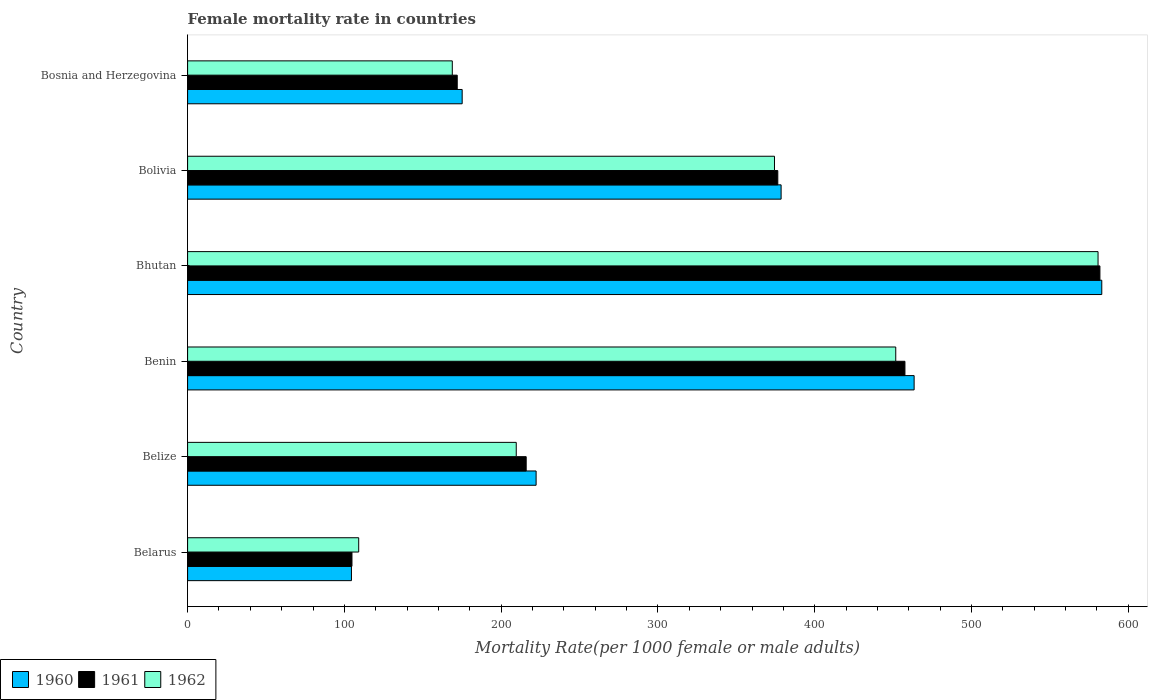How many different coloured bars are there?
Your response must be concise. 3. How many groups of bars are there?
Offer a very short reply. 6. How many bars are there on the 6th tick from the top?
Keep it short and to the point. 3. How many bars are there on the 4th tick from the bottom?
Your answer should be very brief. 3. What is the label of the 6th group of bars from the top?
Offer a very short reply. Belarus. In how many cases, is the number of bars for a given country not equal to the number of legend labels?
Offer a very short reply. 0. What is the female mortality rate in 1960 in Bosnia and Herzegovina?
Offer a terse response. 175.12. Across all countries, what is the maximum female mortality rate in 1961?
Offer a terse response. 581.88. Across all countries, what is the minimum female mortality rate in 1960?
Offer a terse response. 104.51. In which country was the female mortality rate in 1962 maximum?
Your answer should be compact. Bhutan. In which country was the female mortality rate in 1961 minimum?
Provide a succinct answer. Belarus. What is the total female mortality rate in 1962 in the graph?
Keep it short and to the point. 1894.24. What is the difference between the female mortality rate in 1960 in Benin and that in Bosnia and Herzegovina?
Make the answer very short. 288.25. What is the difference between the female mortality rate in 1960 in Belize and the female mortality rate in 1962 in Benin?
Offer a terse response. -229.38. What is the average female mortality rate in 1962 per country?
Offer a terse response. 315.71. What is the difference between the female mortality rate in 1962 and female mortality rate in 1961 in Belarus?
Your answer should be very brief. 4.29. In how many countries, is the female mortality rate in 1962 greater than 340 ?
Ensure brevity in your answer.  3. What is the ratio of the female mortality rate in 1960 in Bhutan to that in Bolivia?
Offer a very short reply. 1.54. Is the difference between the female mortality rate in 1962 in Belarus and Bhutan greater than the difference between the female mortality rate in 1961 in Belarus and Bhutan?
Offer a terse response. Yes. What is the difference between the highest and the second highest female mortality rate in 1961?
Your answer should be very brief. 124.36. What is the difference between the highest and the lowest female mortality rate in 1960?
Make the answer very short. 478.56. In how many countries, is the female mortality rate in 1960 greater than the average female mortality rate in 1960 taken over all countries?
Offer a terse response. 3. Is the sum of the female mortality rate in 1962 in Benin and Bosnia and Herzegovina greater than the maximum female mortality rate in 1961 across all countries?
Provide a short and direct response. Yes. What does the 2nd bar from the top in Belarus represents?
Offer a very short reply. 1961. How many bars are there?
Your response must be concise. 18. Are all the bars in the graph horizontal?
Provide a short and direct response. Yes. Are the values on the major ticks of X-axis written in scientific E-notation?
Make the answer very short. No. Does the graph contain any zero values?
Give a very brief answer. No. How many legend labels are there?
Your answer should be compact. 3. How are the legend labels stacked?
Offer a terse response. Horizontal. What is the title of the graph?
Your answer should be very brief. Female mortality rate in countries. Does "1961" appear as one of the legend labels in the graph?
Offer a very short reply. Yes. What is the label or title of the X-axis?
Your answer should be compact. Mortality Rate(per 1000 female or male adults). What is the Mortality Rate(per 1000 female or male adults) in 1960 in Belarus?
Give a very brief answer. 104.51. What is the Mortality Rate(per 1000 female or male adults) of 1961 in Belarus?
Keep it short and to the point. 104.84. What is the Mortality Rate(per 1000 female or male adults) of 1962 in Belarus?
Give a very brief answer. 109.13. What is the Mortality Rate(per 1000 female or male adults) of 1960 in Belize?
Give a very brief answer. 222.28. What is the Mortality Rate(per 1000 female or male adults) of 1961 in Belize?
Keep it short and to the point. 215.95. What is the Mortality Rate(per 1000 female or male adults) in 1962 in Belize?
Provide a short and direct response. 209.62. What is the Mortality Rate(per 1000 female or male adults) of 1960 in Benin?
Make the answer very short. 463.38. What is the Mortality Rate(per 1000 female or male adults) in 1961 in Benin?
Your answer should be very brief. 457.52. What is the Mortality Rate(per 1000 female or male adults) in 1962 in Benin?
Your answer should be compact. 451.66. What is the Mortality Rate(per 1000 female or male adults) in 1960 in Bhutan?
Keep it short and to the point. 583.07. What is the Mortality Rate(per 1000 female or male adults) in 1961 in Bhutan?
Offer a very short reply. 581.88. What is the Mortality Rate(per 1000 female or male adults) of 1962 in Bhutan?
Provide a succinct answer. 580.69. What is the Mortality Rate(per 1000 female or male adults) of 1960 in Bolivia?
Give a very brief answer. 378.54. What is the Mortality Rate(per 1000 female or male adults) of 1961 in Bolivia?
Your answer should be compact. 376.43. What is the Mortality Rate(per 1000 female or male adults) of 1962 in Bolivia?
Your answer should be compact. 374.32. What is the Mortality Rate(per 1000 female or male adults) of 1960 in Bosnia and Herzegovina?
Offer a very short reply. 175.12. What is the Mortality Rate(per 1000 female or male adults) in 1961 in Bosnia and Herzegovina?
Offer a very short reply. 171.98. What is the Mortality Rate(per 1000 female or male adults) in 1962 in Bosnia and Herzegovina?
Give a very brief answer. 168.83. Across all countries, what is the maximum Mortality Rate(per 1000 female or male adults) in 1960?
Give a very brief answer. 583.07. Across all countries, what is the maximum Mortality Rate(per 1000 female or male adults) in 1961?
Make the answer very short. 581.88. Across all countries, what is the maximum Mortality Rate(per 1000 female or male adults) in 1962?
Give a very brief answer. 580.69. Across all countries, what is the minimum Mortality Rate(per 1000 female or male adults) in 1960?
Provide a succinct answer. 104.51. Across all countries, what is the minimum Mortality Rate(per 1000 female or male adults) in 1961?
Your answer should be very brief. 104.84. Across all countries, what is the minimum Mortality Rate(per 1000 female or male adults) in 1962?
Make the answer very short. 109.13. What is the total Mortality Rate(per 1000 female or male adults) in 1960 in the graph?
Keep it short and to the point. 1926.9. What is the total Mortality Rate(per 1000 female or male adults) in 1961 in the graph?
Your response must be concise. 1908.59. What is the total Mortality Rate(per 1000 female or male adults) of 1962 in the graph?
Keep it short and to the point. 1894.24. What is the difference between the Mortality Rate(per 1000 female or male adults) in 1960 in Belarus and that in Belize?
Give a very brief answer. -117.77. What is the difference between the Mortality Rate(per 1000 female or male adults) in 1961 in Belarus and that in Belize?
Offer a terse response. -111.11. What is the difference between the Mortality Rate(per 1000 female or male adults) of 1962 in Belarus and that in Belize?
Offer a very short reply. -100.49. What is the difference between the Mortality Rate(per 1000 female or male adults) in 1960 in Belarus and that in Benin?
Give a very brief answer. -358.87. What is the difference between the Mortality Rate(per 1000 female or male adults) of 1961 in Belarus and that in Benin?
Offer a very short reply. -352.68. What is the difference between the Mortality Rate(per 1000 female or male adults) in 1962 in Belarus and that in Benin?
Provide a succinct answer. -342.53. What is the difference between the Mortality Rate(per 1000 female or male adults) in 1960 in Belarus and that in Bhutan?
Make the answer very short. -478.56. What is the difference between the Mortality Rate(per 1000 female or male adults) in 1961 in Belarus and that in Bhutan?
Make the answer very short. -477.04. What is the difference between the Mortality Rate(per 1000 female or male adults) of 1962 in Belarus and that in Bhutan?
Ensure brevity in your answer.  -471.56. What is the difference between the Mortality Rate(per 1000 female or male adults) in 1960 in Belarus and that in Bolivia?
Make the answer very short. -274.03. What is the difference between the Mortality Rate(per 1000 female or male adults) in 1961 in Belarus and that in Bolivia?
Provide a succinct answer. -271.59. What is the difference between the Mortality Rate(per 1000 female or male adults) in 1962 in Belarus and that in Bolivia?
Offer a terse response. -265.19. What is the difference between the Mortality Rate(per 1000 female or male adults) in 1960 in Belarus and that in Bosnia and Herzegovina?
Offer a very short reply. -70.62. What is the difference between the Mortality Rate(per 1000 female or male adults) of 1961 in Belarus and that in Bosnia and Herzegovina?
Keep it short and to the point. -67.14. What is the difference between the Mortality Rate(per 1000 female or male adults) in 1962 in Belarus and that in Bosnia and Herzegovina?
Give a very brief answer. -59.7. What is the difference between the Mortality Rate(per 1000 female or male adults) in 1960 in Belize and that in Benin?
Give a very brief answer. -241.1. What is the difference between the Mortality Rate(per 1000 female or male adults) in 1961 in Belize and that in Benin?
Ensure brevity in your answer.  -241.57. What is the difference between the Mortality Rate(per 1000 female or male adults) of 1962 in Belize and that in Benin?
Provide a succinct answer. -242.04. What is the difference between the Mortality Rate(per 1000 female or male adults) of 1960 in Belize and that in Bhutan?
Your response must be concise. -360.79. What is the difference between the Mortality Rate(per 1000 female or male adults) in 1961 in Belize and that in Bhutan?
Keep it short and to the point. -365.93. What is the difference between the Mortality Rate(per 1000 female or male adults) of 1962 in Belize and that in Bhutan?
Make the answer very short. -371.07. What is the difference between the Mortality Rate(per 1000 female or male adults) of 1960 in Belize and that in Bolivia?
Give a very brief answer. -156.26. What is the difference between the Mortality Rate(per 1000 female or male adults) in 1961 in Belize and that in Bolivia?
Keep it short and to the point. -160.48. What is the difference between the Mortality Rate(per 1000 female or male adults) in 1962 in Belize and that in Bolivia?
Your response must be concise. -164.7. What is the difference between the Mortality Rate(per 1000 female or male adults) in 1960 in Belize and that in Bosnia and Herzegovina?
Your response must be concise. 47.16. What is the difference between the Mortality Rate(per 1000 female or male adults) of 1961 in Belize and that in Bosnia and Herzegovina?
Give a very brief answer. 43.97. What is the difference between the Mortality Rate(per 1000 female or male adults) in 1962 in Belize and that in Bosnia and Herzegovina?
Provide a succinct answer. 40.79. What is the difference between the Mortality Rate(per 1000 female or male adults) in 1960 in Benin and that in Bhutan?
Offer a very short reply. -119.69. What is the difference between the Mortality Rate(per 1000 female or male adults) in 1961 in Benin and that in Bhutan?
Your answer should be compact. -124.36. What is the difference between the Mortality Rate(per 1000 female or male adults) in 1962 in Benin and that in Bhutan?
Make the answer very short. -129.03. What is the difference between the Mortality Rate(per 1000 female or male adults) of 1960 in Benin and that in Bolivia?
Provide a succinct answer. 84.83. What is the difference between the Mortality Rate(per 1000 female or male adults) in 1961 in Benin and that in Bolivia?
Give a very brief answer. 81.09. What is the difference between the Mortality Rate(per 1000 female or male adults) in 1962 in Benin and that in Bolivia?
Keep it short and to the point. 77.34. What is the difference between the Mortality Rate(per 1000 female or male adults) in 1960 in Benin and that in Bosnia and Herzegovina?
Keep it short and to the point. 288.25. What is the difference between the Mortality Rate(per 1000 female or male adults) in 1961 in Benin and that in Bosnia and Herzegovina?
Offer a very short reply. 285.54. What is the difference between the Mortality Rate(per 1000 female or male adults) in 1962 in Benin and that in Bosnia and Herzegovina?
Your response must be concise. 282.83. What is the difference between the Mortality Rate(per 1000 female or male adults) in 1960 in Bhutan and that in Bolivia?
Ensure brevity in your answer.  204.53. What is the difference between the Mortality Rate(per 1000 female or male adults) in 1961 in Bhutan and that in Bolivia?
Provide a short and direct response. 205.45. What is the difference between the Mortality Rate(per 1000 female or male adults) in 1962 in Bhutan and that in Bolivia?
Keep it short and to the point. 206.37. What is the difference between the Mortality Rate(per 1000 female or male adults) of 1960 in Bhutan and that in Bosnia and Herzegovina?
Your answer should be very brief. 407.94. What is the difference between the Mortality Rate(per 1000 female or male adults) in 1961 in Bhutan and that in Bosnia and Herzegovina?
Make the answer very short. 409.9. What is the difference between the Mortality Rate(per 1000 female or male adults) of 1962 in Bhutan and that in Bosnia and Herzegovina?
Your answer should be very brief. 411.86. What is the difference between the Mortality Rate(per 1000 female or male adults) in 1960 in Bolivia and that in Bosnia and Herzegovina?
Your answer should be compact. 203.42. What is the difference between the Mortality Rate(per 1000 female or male adults) in 1961 in Bolivia and that in Bosnia and Herzegovina?
Your response must be concise. 204.45. What is the difference between the Mortality Rate(per 1000 female or male adults) in 1962 in Bolivia and that in Bosnia and Herzegovina?
Offer a terse response. 205.49. What is the difference between the Mortality Rate(per 1000 female or male adults) in 1960 in Belarus and the Mortality Rate(per 1000 female or male adults) in 1961 in Belize?
Give a very brief answer. -111.44. What is the difference between the Mortality Rate(per 1000 female or male adults) in 1960 in Belarus and the Mortality Rate(per 1000 female or male adults) in 1962 in Belize?
Provide a succinct answer. -105.11. What is the difference between the Mortality Rate(per 1000 female or male adults) of 1961 in Belarus and the Mortality Rate(per 1000 female or male adults) of 1962 in Belize?
Provide a short and direct response. -104.78. What is the difference between the Mortality Rate(per 1000 female or male adults) in 1960 in Belarus and the Mortality Rate(per 1000 female or male adults) in 1961 in Benin?
Your answer should be very brief. -353.01. What is the difference between the Mortality Rate(per 1000 female or male adults) in 1960 in Belarus and the Mortality Rate(per 1000 female or male adults) in 1962 in Benin?
Your response must be concise. -347.15. What is the difference between the Mortality Rate(per 1000 female or male adults) in 1961 in Belarus and the Mortality Rate(per 1000 female or male adults) in 1962 in Benin?
Offer a very short reply. -346.82. What is the difference between the Mortality Rate(per 1000 female or male adults) in 1960 in Belarus and the Mortality Rate(per 1000 female or male adults) in 1961 in Bhutan?
Provide a short and direct response. -477.37. What is the difference between the Mortality Rate(per 1000 female or male adults) of 1960 in Belarus and the Mortality Rate(per 1000 female or male adults) of 1962 in Bhutan?
Give a very brief answer. -476.18. What is the difference between the Mortality Rate(per 1000 female or male adults) in 1961 in Belarus and the Mortality Rate(per 1000 female or male adults) in 1962 in Bhutan?
Your answer should be compact. -475.85. What is the difference between the Mortality Rate(per 1000 female or male adults) of 1960 in Belarus and the Mortality Rate(per 1000 female or male adults) of 1961 in Bolivia?
Keep it short and to the point. -271.92. What is the difference between the Mortality Rate(per 1000 female or male adults) in 1960 in Belarus and the Mortality Rate(per 1000 female or male adults) in 1962 in Bolivia?
Offer a very short reply. -269.81. What is the difference between the Mortality Rate(per 1000 female or male adults) in 1961 in Belarus and the Mortality Rate(per 1000 female or male adults) in 1962 in Bolivia?
Provide a short and direct response. -269.48. What is the difference between the Mortality Rate(per 1000 female or male adults) in 1960 in Belarus and the Mortality Rate(per 1000 female or male adults) in 1961 in Bosnia and Herzegovina?
Your answer should be compact. -67.47. What is the difference between the Mortality Rate(per 1000 female or male adults) of 1960 in Belarus and the Mortality Rate(per 1000 female or male adults) of 1962 in Bosnia and Herzegovina?
Your response must be concise. -64.32. What is the difference between the Mortality Rate(per 1000 female or male adults) in 1961 in Belarus and the Mortality Rate(per 1000 female or male adults) in 1962 in Bosnia and Herzegovina?
Provide a short and direct response. -63.99. What is the difference between the Mortality Rate(per 1000 female or male adults) of 1960 in Belize and the Mortality Rate(per 1000 female or male adults) of 1961 in Benin?
Ensure brevity in your answer.  -235.24. What is the difference between the Mortality Rate(per 1000 female or male adults) of 1960 in Belize and the Mortality Rate(per 1000 female or male adults) of 1962 in Benin?
Make the answer very short. -229.38. What is the difference between the Mortality Rate(per 1000 female or male adults) of 1961 in Belize and the Mortality Rate(per 1000 female or male adults) of 1962 in Benin?
Give a very brief answer. -235.71. What is the difference between the Mortality Rate(per 1000 female or male adults) of 1960 in Belize and the Mortality Rate(per 1000 female or male adults) of 1961 in Bhutan?
Offer a terse response. -359.6. What is the difference between the Mortality Rate(per 1000 female or male adults) in 1960 in Belize and the Mortality Rate(per 1000 female or male adults) in 1962 in Bhutan?
Keep it short and to the point. -358.41. What is the difference between the Mortality Rate(per 1000 female or male adults) of 1961 in Belize and the Mortality Rate(per 1000 female or male adults) of 1962 in Bhutan?
Your answer should be compact. -364.74. What is the difference between the Mortality Rate(per 1000 female or male adults) in 1960 in Belize and the Mortality Rate(per 1000 female or male adults) in 1961 in Bolivia?
Provide a short and direct response. -154.15. What is the difference between the Mortality Rate(per 1000 female or male adults) of 1960 in Belize and the Mortality Rate(per 1000 female or male adults) of 1962 in Bolivia?
Offer a very short reply. -152.04. What is the difference between the Mortality Rate(per 1000 female or male adults) in 1961 in Belize and the Mortality Rate(per 1000 female or male adults) in 1962 in Bolivia?
Keep it short and to the point. -158.37. What is the difference between the Mortality Rate(per 1000 female or male adults) of 1960 in Belize and the Mortality Rate(per 1000 female or male adults) of 1961 in Bosnia and Herzegovina?
Offer a very short reply. 50.3. What is the difference between the Mortality Rate(per 1000 female or male adults) of 1960 in Belize and the Mortality Rate(per 1000 female or male adults) of 1962 in Bosnia and Herzegovina?
Ensure brevity in your answer.  53.45. What is the difference between the Mortality Rate(per 1000 female or male adults) in 1961 in Belize and the Mortality Rate(per 1000 female or male adults) in 1962 in Bosnia and Herzegovina?
Provide a short and direct response. 47.12. What is the difference between the Mortality Rate(per 1000 female or male adults) in 1960 in Benin and the Mortality Rate(per 1000 female or male adults) in 1961 in Bhutan?
Offer a terse response. -118.5. What is the difference between the Mortality Rate(per 1000 female or male adults) of 1960 in Benin and the Mortality Rate(per 1000 female or male adults) of 1962 in Bhutan?
Ensure brevity in your answer.  -117.31. What is the difference between the Mortality Rate(per 1000 female or male adults) in 1961 in Benin and the Mortality Rate(per 1000 female or male adults) in 1962 in Bhutan?
Offer a terse response. -123.17. What is the difference between the Mortality Rate(per 1000 female or male adults) of 1960 in Benin and the Mortality Rate(per 1000 female or male adults) of 1961 in Bolivia?
Ensure brevity in your answer.  86.95. What is the difference between the Mortality Rate(per 1000 female or male adults) in 1960 in Benin and the Mortality Rate(per 1000 female or male adults) in 1962 in Bolivia?
Make the answer very short. 89.06. What is the difference between the Mortality Rate(per 1000 female or male adults) in 1961 in Benin and the Mortality Rate(per 1000 female or male adults) in 1962 in Bolivia?
Offer a very short reply. 83.2. What is the difference between the Mortality Rate(per 1000 female or male adults) in 1960 in Benin and the Mortality Rate(per 1000 female or male adults) in 1961 in Bosnia and Herzegovina?
Your answer should be compact. 291.4. What is the difference between the Mortality Rate(per 1000 female or male adults) of 1960 in Benin and the Mortality Rate(per 1000 female or male adults) of 1962 in Bosnia and Herzegovina?
Ensure brevity in your answer.  294.55. What is the difference between the Mortality Rate(per 1000 female or male adults) in 1961 in Benin and the Mortality Rate(per 1000 female or male adults) in 1962 in Bosnia and Herzegovina?
Your answer should be compact. 288.69. What is the difference between the Mortality Rate(per 1000 female or male adults) in 1960 in Bhutan and the Mortality Rate(per 1000 female or male adults) in 1961 in Bolivia?
Make the answer very short. 206.64. What is the difference between the Mortality Rate(per 1000 female or male adults) of 1960 in Bhutan and the Mortality Rate(per 1000 female or male adults) of 1962 in Bolivia?
Make the answer very short. 208.75. What is the difference between the Mortality Rate(per 1000 female or male adults) in 1961 in Bhutan and the Mortality Rate(per 1000 female or male adults) in 1962 in Bolivia?
Offer a very short reply. 207.56. What is the difference between the Mortality Rate(per 1000 female or male adults) in 1960 in Bhutan and the Mortality Rate(per 1000 female or male adults) in 1961 in Bosnia and Herzegovina?
Ensure brevity in your answer.  411.09. What is the difference between the Mortality Rate(per 1000 female or male adults) of 1960 in Bhutan and the Mortality Rate(per 1000 female or male adults) of 1962 in Bosnia and Herzegovina?
Ensure brevity in your answer.  414.24. What is the difference between the Mortality Rate(per 1000 female or male adults) in 1961 in Bhutan and the Mortality Rate(per 1000 female or male adults) in 1962 in Bosnia and Herzegovina?
Make the answer very short. 413.05. What is the difference between the Mortality Rate(per 1000 female or male adults) of 1960 in Bolivia and the Mortality Rate(per 1000 female or male adults) of 1961 in Bosnia and Herzegovina?
Offer a very short reply. 206.57. What is the difference between the Mortality Rate(per 1000 female or male adults) of 1960 in Bolivia and the Mortality Rate(per 1000 female or male adults) of 1962 in Bosnia and Herzegovina?
Provide a short and direct response. 209.71. What is the difference between the Mortality Rate(per 1000 female or male adults) of 1961 in Bolivia and the Mortality Rate(per 1000 female or male adults) of 1962 in Bosnia and Herzegovina?
Offer a very short reply. 207.6. What is the average Mortality Rate(per 1000 female or male adults) of 1960 per country?
Your answer should be very brief. 321.15. What is the average Mortality Rate(per 1000 female or male adults) in 1961 per country?
Your answer should be compact. 318.1. What is the average Mortality Rate(per 1000 female or male adults) of 1962 per country?
Offer a terse response. 315.71. What is the difference between the Mortality Rate(per 1000 female or male adults) of 1960 and Mortality Rate(per 1000 female or male adults) of 1961 in Belarus?
Provide a short and direct response. -0.33. What is the difference between the Mortality Rate(per 1000 female or male adults) of 1960 and Mortality Rate(per 1000 female or male adults) of 1962 in Belarus?
Offer a terse response. -4.62. What is the difference between the Mortality Rate(per 1000 female or male adults) in 1961 and Mortality Rate(per 1000 female or male adults) in 1962 in Belarus?
Provide a succinct answer. -4.29. What is the difference between the Mortality Rate(per 1000 female or male adults) in 1960 and Mortality Rate(per 1000 female or male adults) in 1961 in Belize?
Offer a terse response. 6.33. What is the difference between the Mortality Rate(per 1000 female or male adults) of 1960 and Mortality Rate(per 1000 female or male adults) of 1962 in Belize?
Your answer should be compact. 12.66. What is the difference between the Mortality Rate(per 1000 female or male adults) in 1961 and Mortality Rate(per 1000 female or male adults) in 1962 in Belize?
Your answer should be very brief. 6.33. What is the difference between the Mortality Rate(per 1000 female or male adults) in 1960 and Mortality Rate(per 1000 female or male adults) in 1961 in Benin?
Make the answer very short. 5.86. What is the difference between the Mortality Rate(per 1000 female or male adults) in 1960 and Mortality Rate(per 1000 female or male adults) in 1962 in Benin?
Make the answer very short. 11.72. What is the difference between the Mortality Rate(per 1000 female or male adults) in 1961 and Mortality Rate(per 1000 female or male adults) in 1962 in Benin?
Keep it short and to the point. 5.86. What is the difference between the Mortality Rate(per 1000 female or male adults) of 1960 and Mortality Rate(per 1000 female or male adults) of 1961 in Bhutan?
Give a very brief answer. 1.19. What is the difference between the Mortality Rate(per 1000 female or male adults) of 1960 and Mortality Rate(per 1000 female or male adults) of 1962 in Bhutan?
Your answer should be compact. 2.38. What is the difference between the Mortality Rate(per 1000 female or male adults) of 1961 and Mortality Rate(per 1000 female or male adults) of 1962 in Bhutan?
Give a very brief answer. 1.19. What is the difference between the Mortality Rate(per 1000 female or male adults) in 1960 and Mortality Rate(per 1000 female or male adults) in 1961 in Bolivia?
Offer a very short reply. 2.11. What is the difference between the Mortality Rate(per 1000 female or male adults) of 1960 and Mortality Rate(per 1000 female or male adults) of 1962 in Bolivia?
Your answer should be compact. 4.22. What is the difference between the Mortality Rate(per 1000 female or male adults) in 1961 and Mortality Rate(per 1000 female or male adults) in 1962 in Bolivia?
Your answer should be compact. 2.11. What is the difference between the Mortality Rate(per 1000 female or male adults) of 1960 and Mortality Rate(per 1000 female or male adults) of 1961 in Bosnia and Herzegovina?
Your answer should be compact. 3.15. What is the difference between the Mortality Rate(per 1000 female or male adults) of 1960 and Mortality Rate(per 1000 female or male adults) of 1962 in Bosnia and Herzegovina?
Provide a succinct answer. 6.29. What is the difference between the Mortality Rate(per 1000 female or male adults) of 1961 and Mortality Rate(per 1000 female or male adults) of 1962 in Bosnia and Herzegovina?
Ensure brevity in your answer.  3.15. What is the ratio of the Mortality Rate(per 1000 female or male adults) in 1960 in Belarus to that in Belize?
Your answer should be compact. 0.47. What is the ratio of the Mortality Rate(per 1000 female or male adults) in 1961 in Belarus to that in Belize?
Your answer should be very brief. 0.49. What is the ratio of the Mortality Rate(per 1000 female or male adults) in 1962 in Belarus to that in Belize?
Keep it short and to the point. 0.52. What is the ratio of the Mortality Rate(per 1000 female or male adults) in 1960 in Belarus to that in Benin?
Offer a very short reply. 0.23. What is the ratio of the Mortality Rate(per 1000 female or male adults) of 1961 in Belarus to that in Benin?
Your answer should be compact. 0.23. What is the ratio of the Mortality Rate(per 1000 female or male adults) in 1962 in Belarus to that in Benin?
Offer a very short reply. 0.24. What is the ratio of the Mortality Rate(per 1000 female or male adults) in 1960 in Belarus to that in Bhutan?
Give a very brief answer. 0.18. What is the ratio of the Mortality Rate(per 1000 female or male adults) in 1961 in Belarus to that in Bhutan?
Give a very brief answer. 0.18. What is the ratio of the Mortality Rate(per 1000 female or male adults) of 1962 in Belarus to that in Bhutan?
Your response must be concise. 0.19. What is the ratio of the Mortality Rate(per 1000 female or male adults) in 1960 in Belarus to that in Bolivia?
Your response must be concise. 0.28. What is the ratio of the Mortality Rate(per 1000 female or male adults) of 1961 in Belarus to that in Bolivia?
Your answer should be compact. 0.28. What is the ratio of the Mortality Rate(per 1000 female or male adults) in 1962 in Belarus to that in Bolivia?
Ensure brevity in your answer.  0.29. What is the ratio of the Mortality Rate(per 1000 female or male adults) in 1960 in Belarus to that in Bosnia and Herzegovina?
Make the answer very short. 0.6. What is the ratio of the Mortality Rate(per 1000 female or male adults) in 1961 in Belarus to that in Bosnia and Herzegovina?
Your response must be concise. 0.61. What is the ratio of the Mortality Rate(per 1000 female or male adults) of 1962 in Belarus to that in Bosnia and Herzegovina?
Offer a very short reply. 0.65. What is the ratio of the Mortality Rate(per 1000 female or male adults) in 1960 in Belize to that in Benin?
Offer a terse response. 0.48. What is the ratio of the Mortality Rate(per 1000 female or male adults) in 1961 in Belize to that in Benin?
Offer a very short reply. 0.47. What is the ratio of the Mortality Rate(per 1000 female or male adults) in 1962 in Belize to that in Benin?
Provide a succinct answer. 0.46. What is the ratio of the Mortality Rate(per 1000 female or male adults) of 1960 in Belize to that in Bhutan?
Provide a short and direct response. 0.38. What is the ratio of the Mortality Rate(per 1000 female or male adults) of 1961 in Belize to that in Bhutan?
Keep it short and to the point. 0.37. What is the ratio of the Mortality Rate(per 1000 female or male adults) in 1962 in Belize to that in Bhutan?
Give a very brief answer. 0.36. What is the ratio of the Mortality Rate(per 1000 female or male adults) of 1960 in Belize to that in Bolivia?
Provide a short and direct response. 0.59. What is the ratio of the Mortality Rate(per 1000 female or male adults) of 1961 in Belize to that in Bolivia?
Your answer should be very brief. 0.57. What is the ratio of the Mortality Rate(per 1000 female or male adults) of 1962 in Belize to that in Bolivia?
Your answer should be very brief. 0.56. What is the ratio of the Mortality Rate(per 1000 female or male adults) in 1960 in Belize to that in Bosnia and Herzegovina?
Offer a very short reply. 1.27. What is the ratio of the Mortality Rate(per 1000 female or male adults) of 1961 in Belize to that in Bosnia and Herzegovina?
Give a very brief answer. 1.26. What is the ratio of the Mortality Rate(per 1000 female or male adults) in 1962 in Belize to that in Bosnia and Herzegovina?
Your answer should be compact. 1.24. What is the ratio of the Mortality Rate(per 1000 female or male adults) in 1960 in Benin to that in Bhutan?
Your response must be concise. 0.79. What is the ratio of the Mortality Rate(per 1000 female or male adults) in 1961 in Benin to that in Bhutan?
Your response must be concise. 0.79. What is the ratio of the Mortality Rate(per 1000 female or male adults) of 1960 in Benin to that in Bolivia?
Give a very brief answer. 1.22. What is the ratio of the Mortality Rate(per 1000 female or male adults) in 1961 in Benin to that in Bolivia?
Make the answer very short. 1.22. What is the ratio of the Mortality Rate(per 1000 female or male adults) in 1962 in Benin to that in Bolivia?
Give a very brief answer. 1.21. What is the ratio of the Mortality Rate(per 1000 female or male adults) of 1960 in Benin to that in Bosnia and Herzegovina?
Offer a terse response. 2.65. What is the ratio of the Mortality Rate(per 1000 female or male adults) of 1961 in Benin to that in Bosnia and Herzegovina?
Your response must be concise. 2.66. What is the ratio of the Mortality Rate(per 1000 female or male adults) in 1962 in Benin to that in Bosnia and Herzegovina?
Provide a short and direct response. 2.68. What is the ratio of the Mortality Rate(per 1000 female or male adults) in 1960 in Bhutan to that in Bolivia?
Make the answer very short. 1.54. What is the ratio of the Mortality Rate(per 1000 female or male adults) in 1961 in Bhutan to that in Bolivia?
Offer a terse response. 1.55. What is the ratio of the Mortality Rate(per 1000 female or male adults) in 1962 in Bhutan to that in Bolivia?
Keep it short and to the point. 1.55. What is the ratio of the Mortality Rate(per 1000 female or male adults) in 1960 in Bhutan to that in Bosnia and Herzegovina?
Your response must be concise. 3.33. What is the ratio of the Mortality Rate(per 1000 female or male adults) in 1961 in Bhutan to that in Bosnia and Herzegovina?
Keep it short and to the point. 3.38. What is the ratio of the Mortality Rate(per 1000 female or male adults) in 1962 in Bhutan to that in Bosnia and Herzegovina?
Ensure brevity in your answer.  3.44. What is the ratio of the Mortality Rate(per 1000 female or male adults) in 1960 in Bolivia to that in Bosnia and Herzegovina?
Your answer should be compact. 2.16. What is the ratio of the Mortality Rate(per 1000 female or male adults) of 1961 in Bolivia to that in Bosnia and Herzegovina?
Offer a very short reply. 2.19. What is the ratio of the Mortality Rate(per 1000 female or male adults) of 1962 in Bolivia to that in Bosnia and Herzegovina?
Ensure brevity in your answer.  2.22. What is the difference between the highest and the second highest Mortality Rate(per 1000 female or male adults) of 1960?
Offer a very short reply. 119.69. What is the difference between the highest and the second highest Mortality Rate(per 1000 female or male adults) in 1961?
Your answer should be very brief. 124.36. What is the difference between the highest and the second highest Mortality Rate(per 1000 female or male adults) of 1962?
Your response must be concise. 129.03. What is the difference between the highest and the lowest Mortality Rate(per 1000 female or male adults) in 1960?
Offer a very short reply. 478.56. What is the difference between the highest and the lowest Mortality Rate(per 1000 female or male adults) of 1961?
Provide a succinct answer. 477.04. What is the difference between the highest and the lowest Mortality Rate(per 1000 female or male adults) of 1962?
Provide a short and direct response. 471.56. 